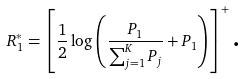Convert formula to latex. <formula><loc_0><loc_0><loc_500><loc_500>R _ { 1 } ^ { * } = \left [ \frac { 1 } { 2 } \log \left ( \frac { P _ { 1 } } { \sum _ { j = 1 } ^ { K } P _ { j } } + P _ { 1 } \right ) \right ] ^ { + } \text  .</formula> 